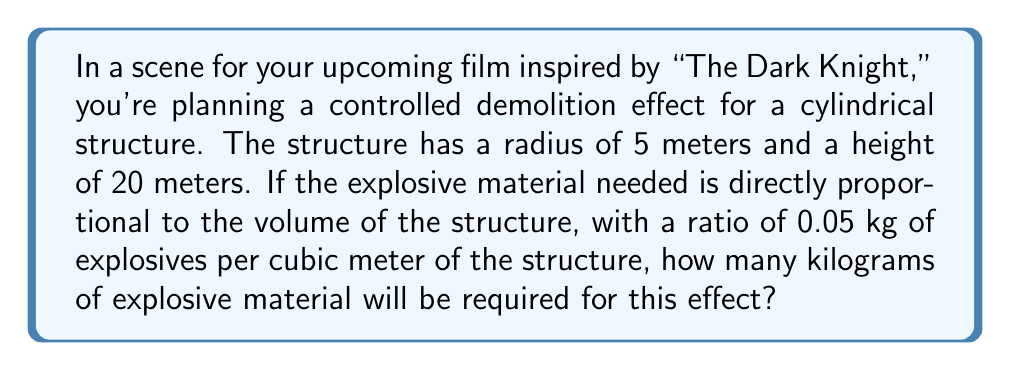What is the answer to this math problem? To solve this problem, we need to follow these steps:

1) First, we need to calculate the volume of the cylindrical structure. The formula for the volume of a cylinder is:

   $$V = \pi r^2 h$$

   where $r$ is the radius and $h$ is the height.

2) Substituting the given values:

   $$V = \pi \cdot 5^2 \cdot 20$$

3) Simplify:

   $$V = \pi \cdot 25 \cdot 20 = 500\pi$$

4) Calculate the value (rounded to two decimal places):

   $$V \approx 1570.80 \text{ m}^3$$

5) Now, we need to calculate the amount of explosives needed. We're given that the ratio is 0.05 kg of explosives per cubic meter of the structure. So we multiply the volume by this ratio:

   $$\text{Explosives needed} = 1570.80 \cdot 0.05 = 78.54 \text{ kg}$$

Therefore, approximately 78.54 kg of explosive material will be required for this controlled demolition effect.
Answer: 78.54 kg 